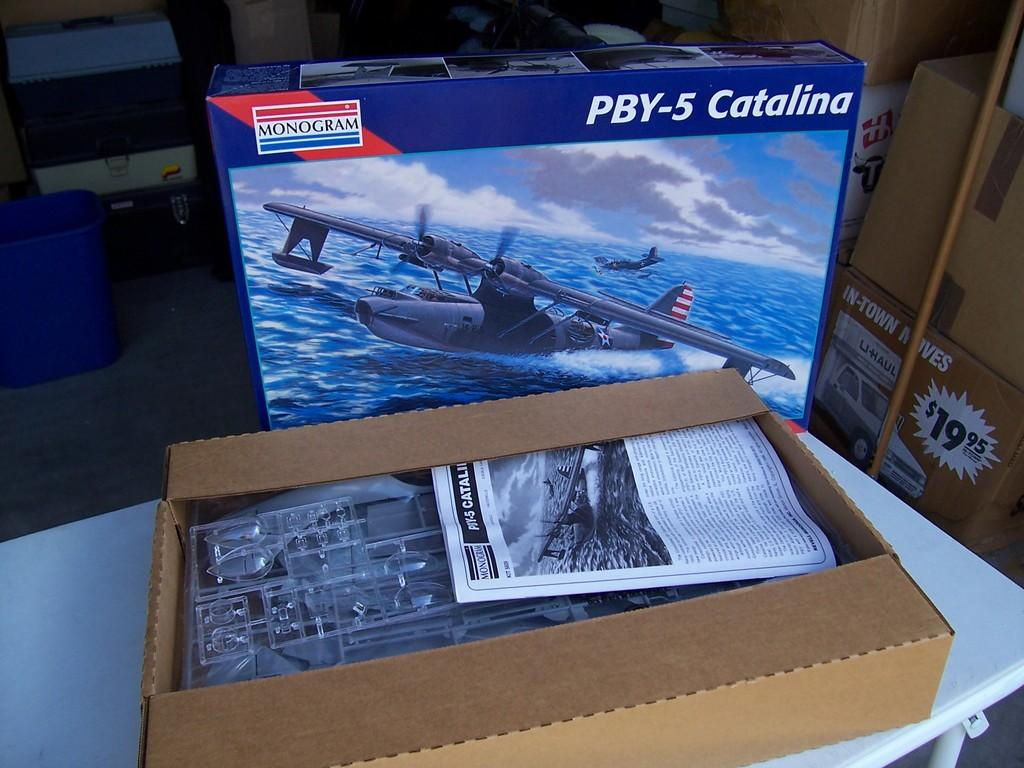Provide a one-sentence caption for the provided image. A model airplane set for a PBY-5 Catalina airplane. 